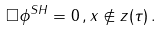Convert formula to latex. <formula><loc_0><loc_0><loc_500><loc_500>\Box \phi ^ { S H } = 0 \, , x \not \in z ( \tau ) \, .</formula> 